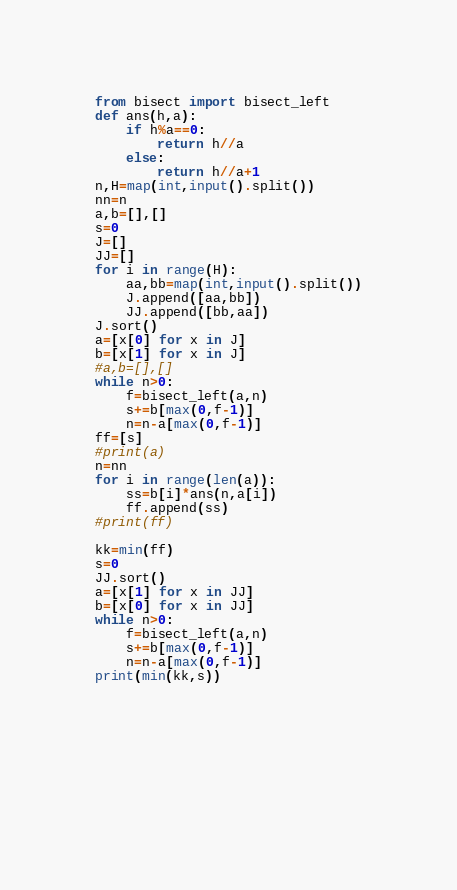<code> <loc_0><loc_0><loc_500><loc_500><_Python_>from bisect import bisect_left
def ans(h,a):
    if h%a==0:
        return h//a 
    else:
        return h//a+1
n,H=map(int,input().split())
nn=n
a,b=[],[]
s=0
J=[]
JJ=[]
for i in range(H):
    aa,bb=map(int,input().split())
    J.append([aa,bb])
    JJ.append([bb,aa])
J.sort()
a=[x[0] for x in J]
b=[x[1] for x in J]
#a,b=[],[]
while n>0:
    f=bisect_left(a,n)
    s+=b[max(0,f-1)]
    n=n-a[max(0,f-1)]
ff=[s]
#print(a)
n=nn
for i in range(len(a)):
    ss=b[i]*ans(n,a[i])
    ff.append(ss)
#print(ff)

kk=min(ff)
s=0
JJ.sort()
a=[x[1] for x in JJ]
b=[x[0] for x in JJ]
while n>0:
    f=bisect_left(a,n)
    s+=b[max(0,f-1)]
    n=n-a[max(0,f-1)]
print(min(kk,s))







 
</code> 